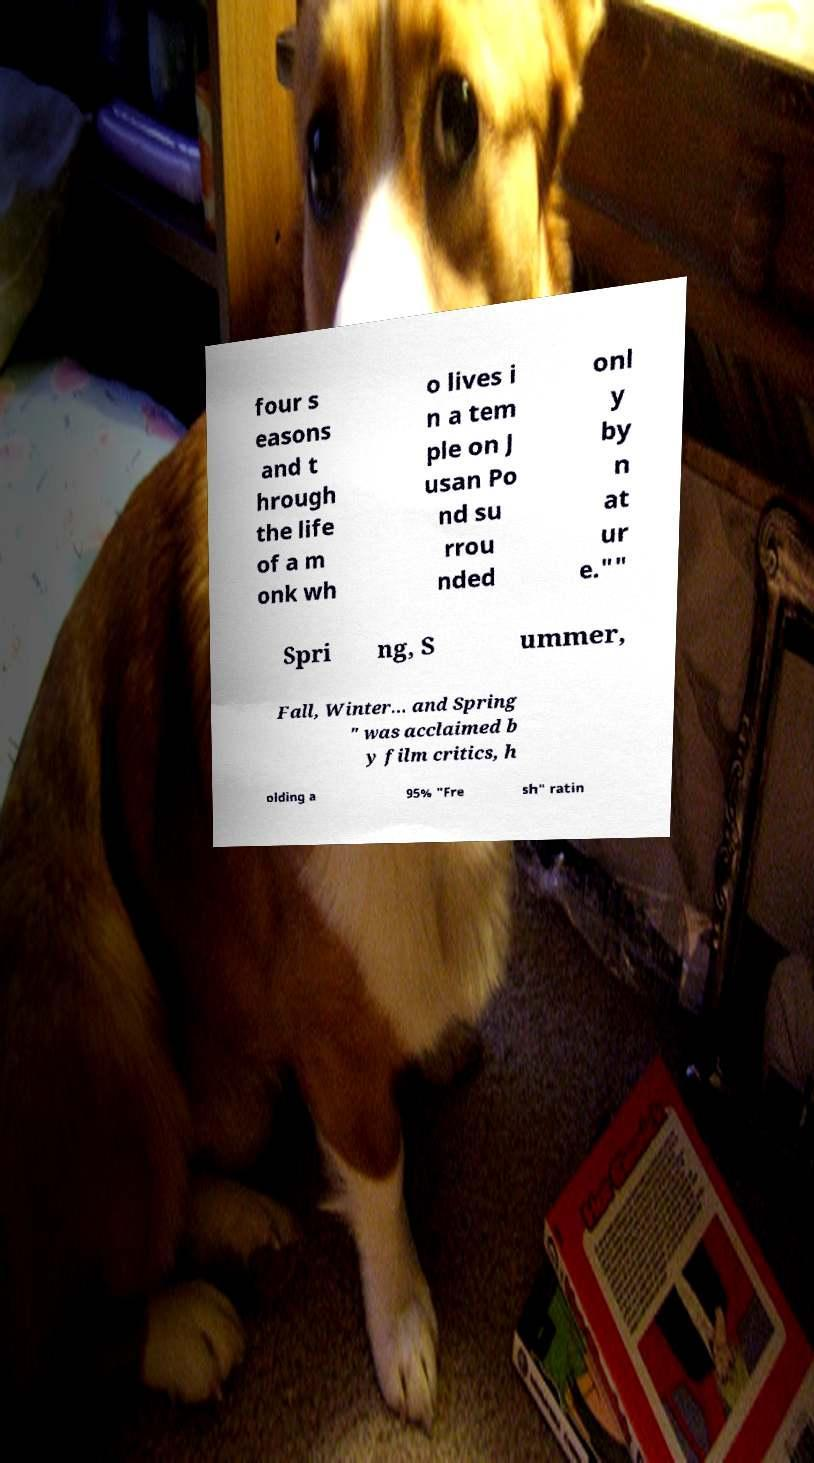I need the written content from this picture converted into text. Can you do that? four s easons and t hrough the life of a m onk wh o lives i n a tem ple on J usan Po nd su rrou nded onl y by n at ur e."" Spri ng, S ummer, Fall, Winter... and Spring " was acclaimed b y film critics, h olding a 95% "Fre sh" ratin 